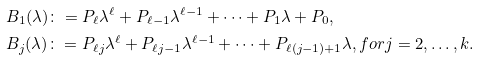<formula> <loc_0><loc_0><loc_500><loc_500>& B _ { 1 } ( \lambda ) \colon = P _ { \ell } \lambda ^ { \ell } + P _ { \ell - 1 } \lambda ^ { \ell - 1 } + \cdots + P _ { 1 } \lambda + P _ { 0 } , \\ & B _ { j } ( \lambda ) \colon = P _ { \ell j } \lambda ^ { \ell } + P _ { \ell j - 1 } \lambda ^ { \ell - 1 } + \cdots + P _ { \ell ( j - 1 ) + 1 } \lambda , f o r j = 2 , \hdots , k .</formula> 